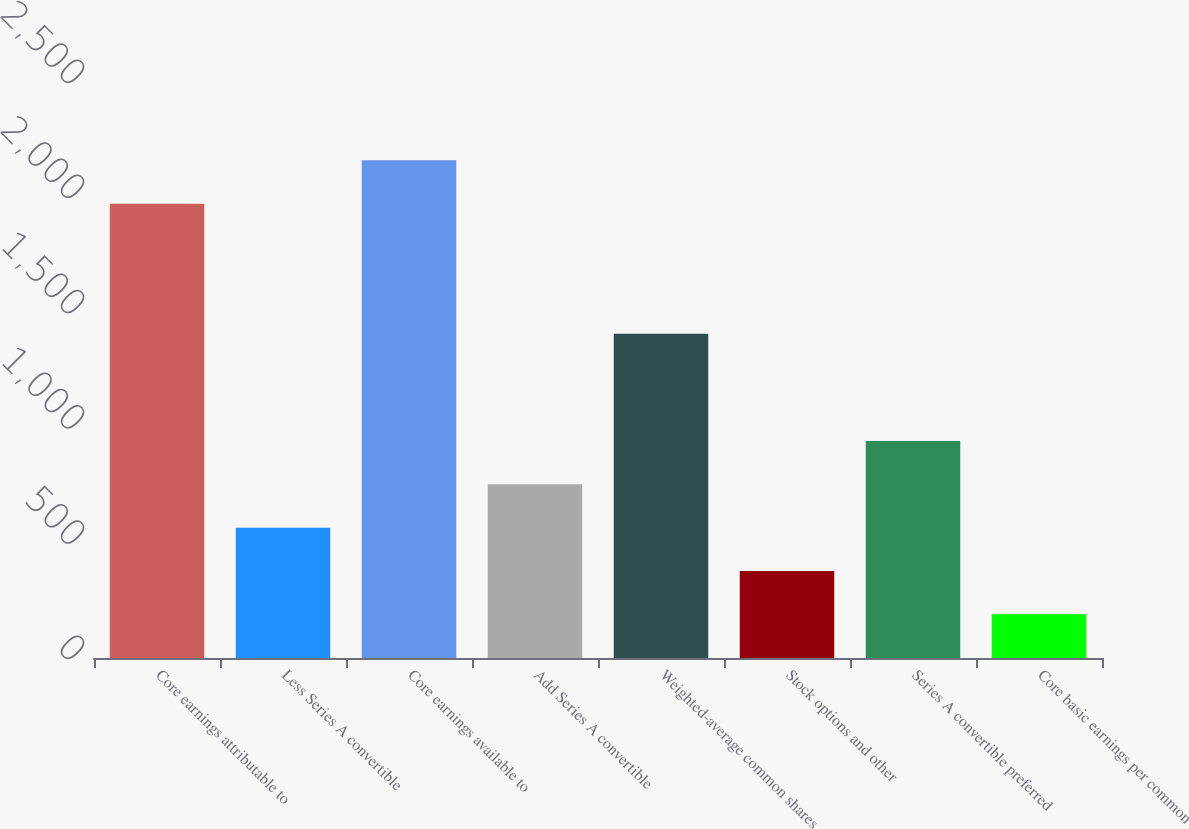Convert chart to OTSL. <chart><loc_0><loc_0><loc_500><loc_500><bar_chart><fcel>Core earnings attributable to<fcel>Less Series A convertible<fcel>Core earnings available to<fcel>Add Series A convertible<fcel>Weighted-average common shares<fcel>Stock options and other<fcel>Series A convertible preferred<fcel>Core basic earnings per common<nl><fcel>1972.06<fcel>565.58<fcel>2160.12<fcel>753.64<fcel>1407.06<fcel>377.52<fcel>941.7<fcel>189.46<nl></chart> 